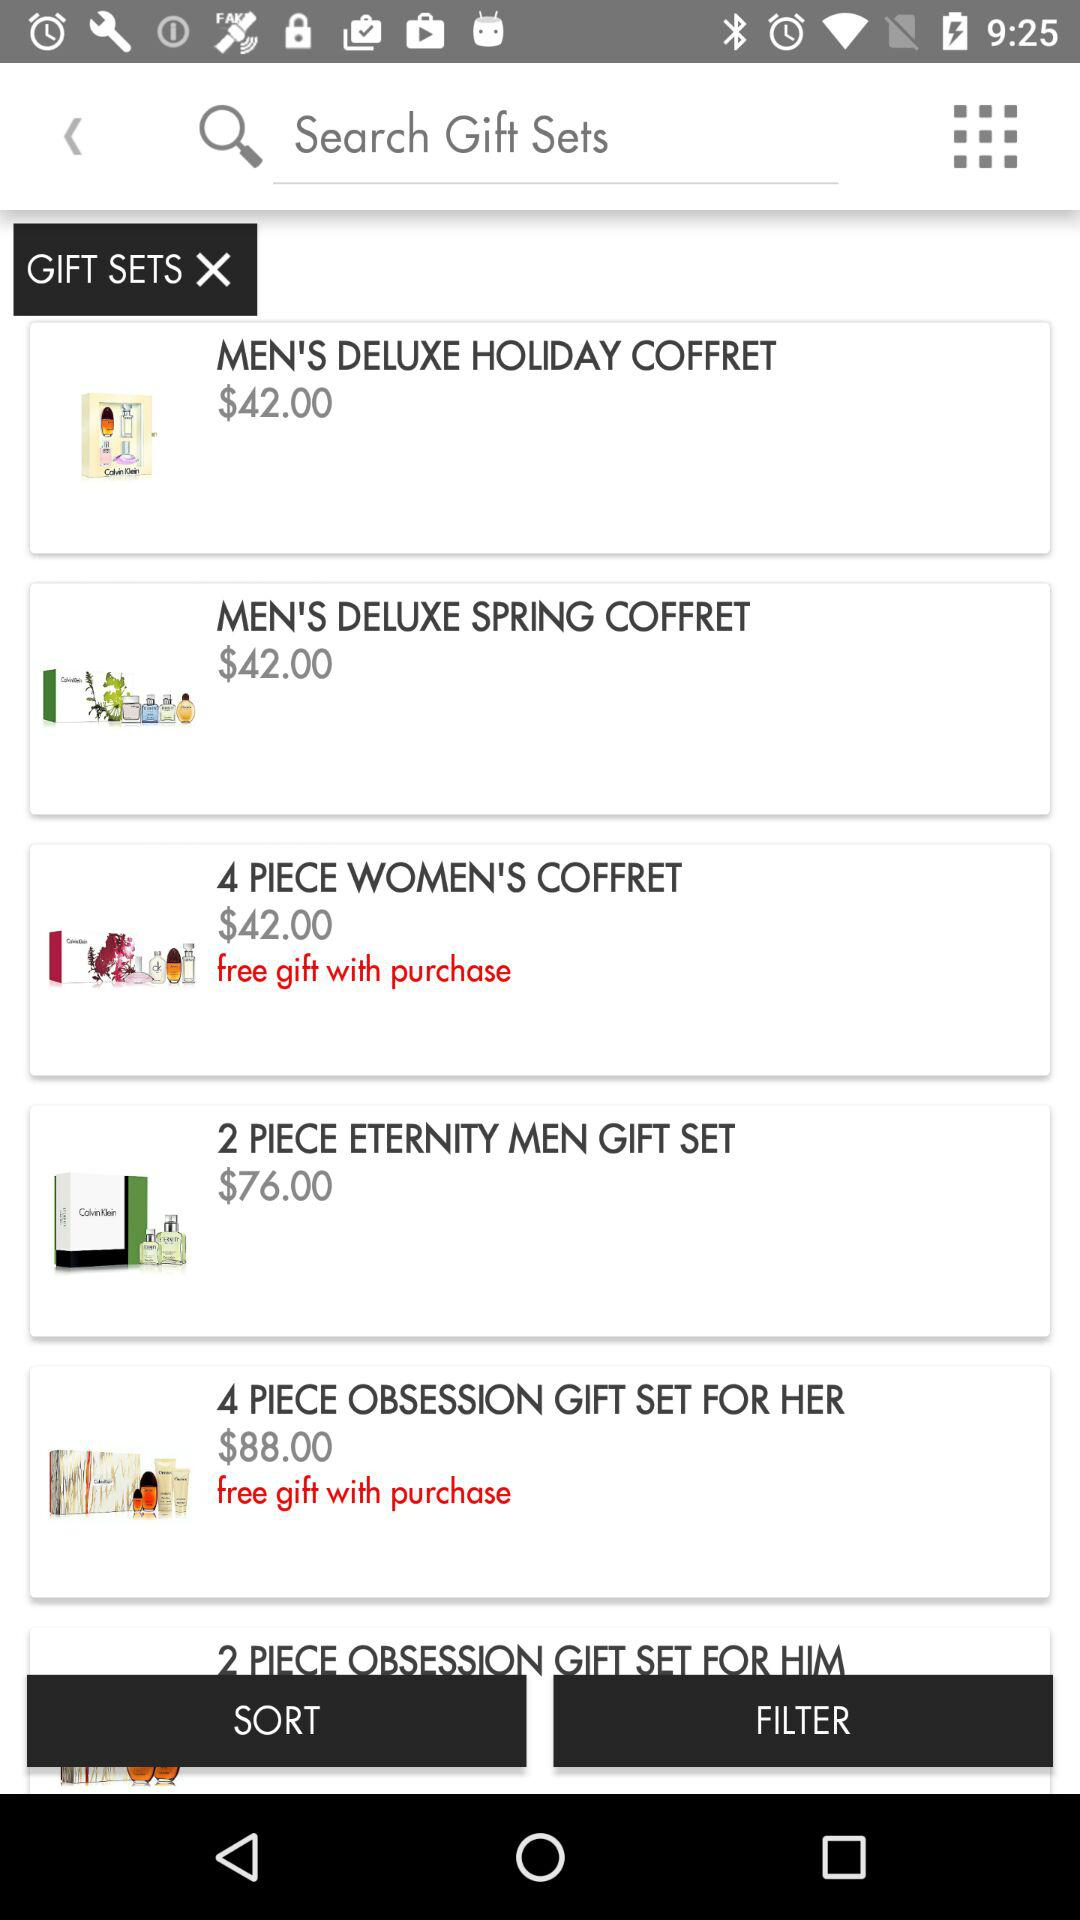What is the price of "MEN'S DELUXE SPRING COFFRET"? The price is $42. 